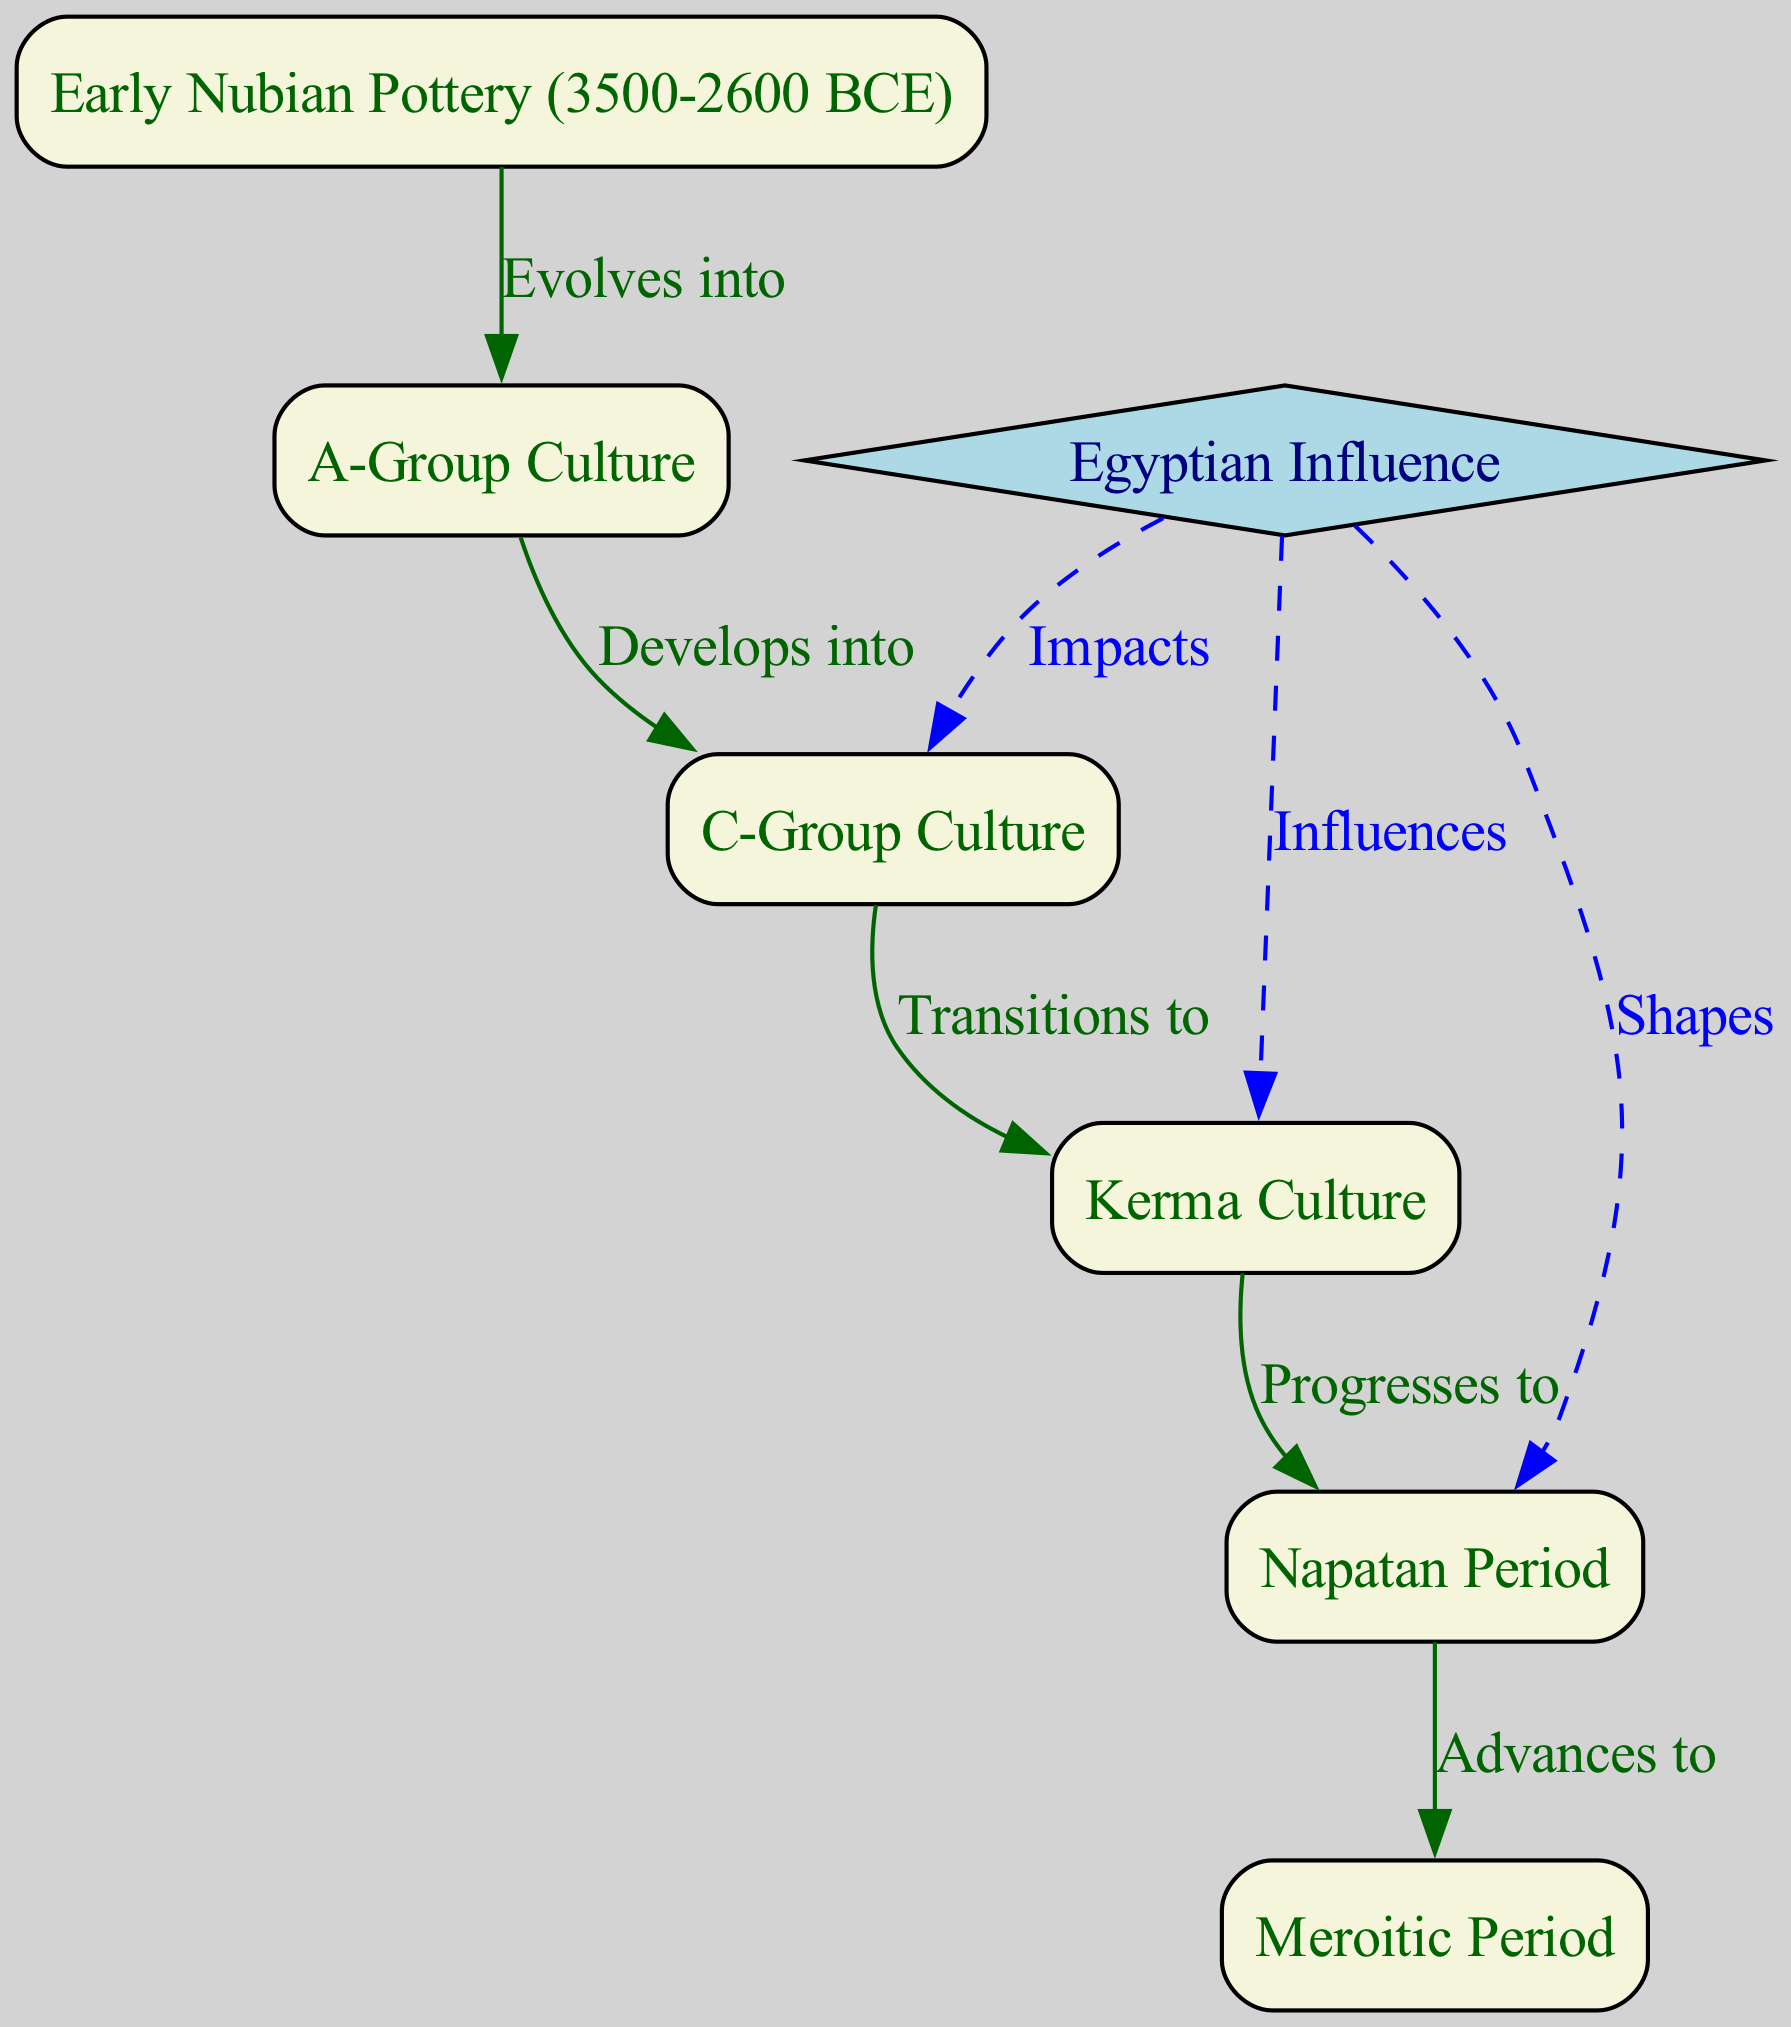What is the earliest pottery style shown in the diagram? The diagram begins with "Early Nubian Pottery (3500-2600 BCE)" as the first node, indicating that this is the earliest pottery style depicted.
Answer: Early Nubian Pottery (3500-2600 BCE) Which pottery culture develops from the A-Group Culture? The flow chart shows a direct connection from "A-Group Culture" to "C-Group Culture," indicating that "C-Group Culture" evolves from it.
Answer: C-Group Culture How many pottery styles are listed in the diagram? By counting the nodes in the diagram, there are a total of six pottery styles and cultural periods represented (1-6), plus the Egyptian Influence node, making it seven.
Answer: 7 What type of connection does Egyptian Influence have with C-Group Culture? The diagram indicates that Egyptian Influence "Impacts" C-Group Culture through a dashed blue edge, showing a specific form of connection.
Answer: Impacts Which pottery culture progresses directly to the Napatan Period? The flow chart states that the "Kerma Culture" transitions to the "Napatan Period," indicating this direct progression.
Answer: Napatan Period What shapes the Meroitic Period according to the diagram? The diagram highlights that "Egyptian Influence" shapes the "Meroitic Period," which is shown with a dashed line, signifying influence.
Answer: Egyptian Influence What is the last pottery culture in the sequence provided? The flow chart ends with "Meroitic Period," which is the last node in the progression of pottery styles and techniques.
Answer: Meroitic Period Which two pottery cultures does Egyptian Influence influence? The diagram shows that Egyptian Influence influences both the "Kerma Culture" and the "C-Group Culture," as indicated by the edges connecting to those nodes.
Answer: Kerma Culture, C-Group Culture 